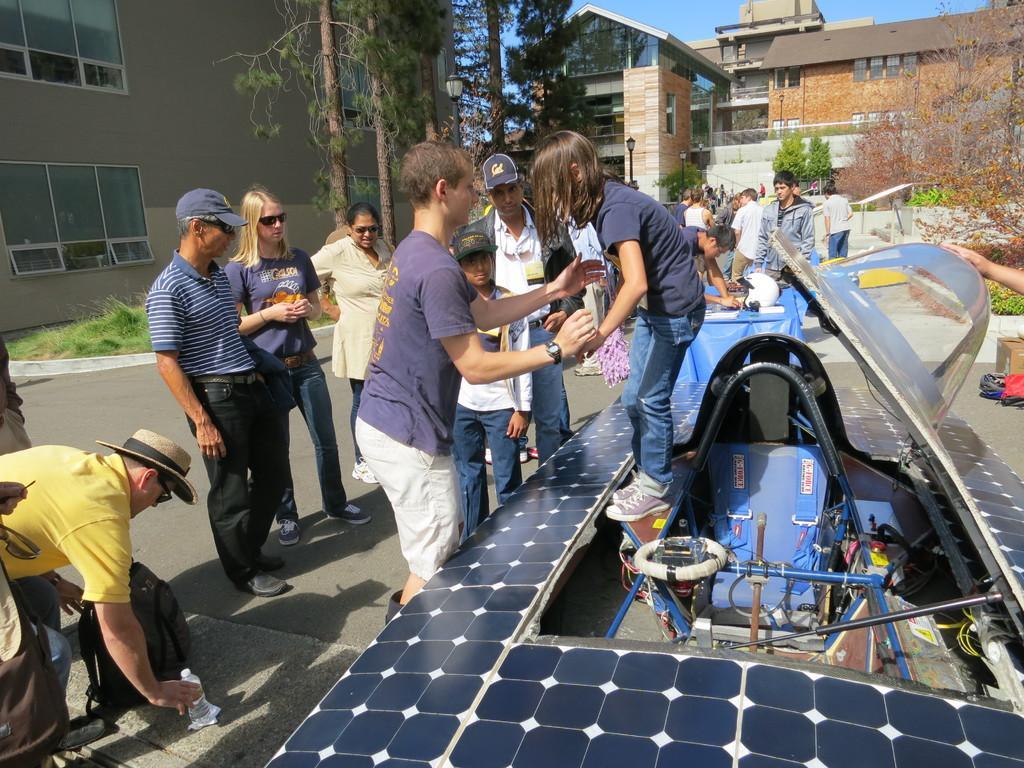Please provide a concise description of this image. In this image I can see number of persons are standing on the ground, a girl standing on the object which is blue in color. I can see a water bottle and a bag on the ground. In the background I can see few persons standing on the ground, few trees, few buildings and the sky. 